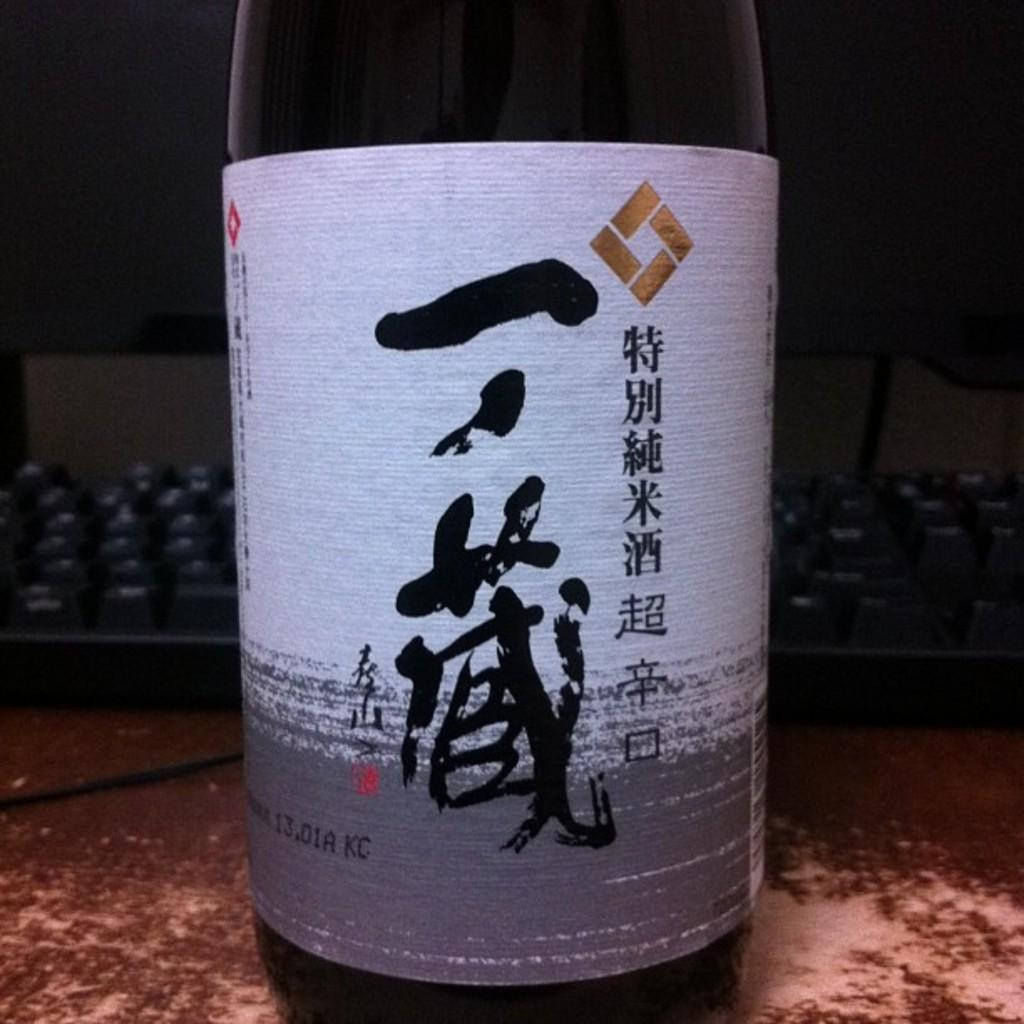What type of object is on the table in the image? There is a beverage bottle in the image. What other object can be seen on the table in the image? There is a keyboard in the image. What is the largest object on the table in the image? There is a desktop in the image, which is likely the largest object. Where are all these objects located in the image? All of these objects are on a table. What type of poison is present in the image? There is no poison present in the image. What route is visible in the image? There is no route visible in the image. 